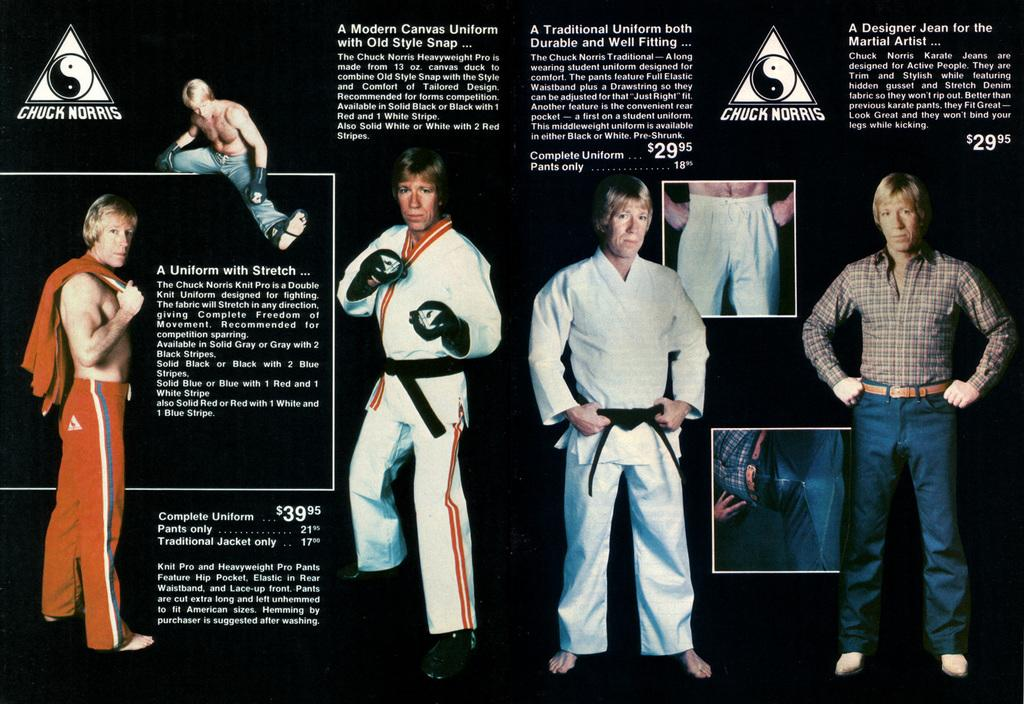What type of image is being described? The image is a poster. What can be seen in the poster? There are men in different positions in the poster. Are there any words or phrases on the poster? Yes, there is text present in the poster. How many balls are being juggled by the men in the poster? There are no balls present in the poster; it features men in different positions with text. 